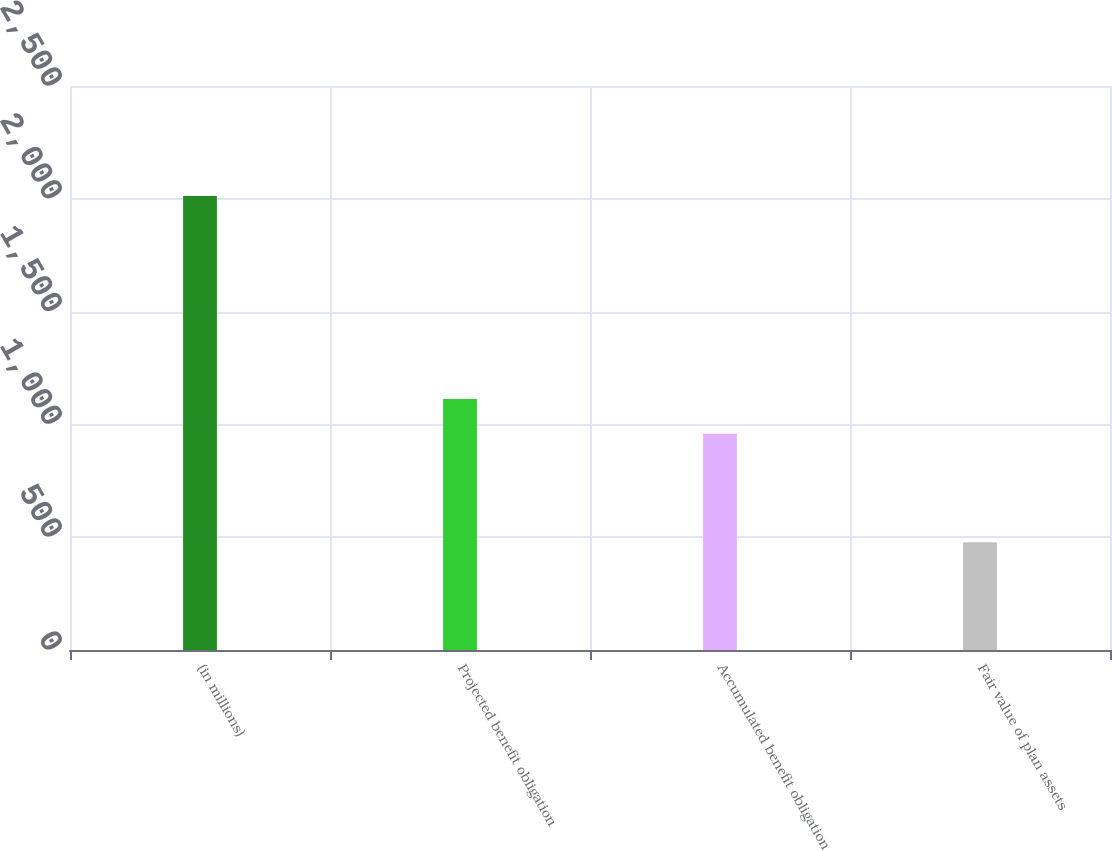<chart> <loc_0><loc_0><loc_500><loc_500><bar_chart><fcel>(in millions)<fcel>Projected benefit obligation<fcel>Accumulated benefit obligation<fcel>Fair value of plan assets<nl><fcel>2012<fcel>1112.4<fcel>959<fcel>478<nl></chart> 